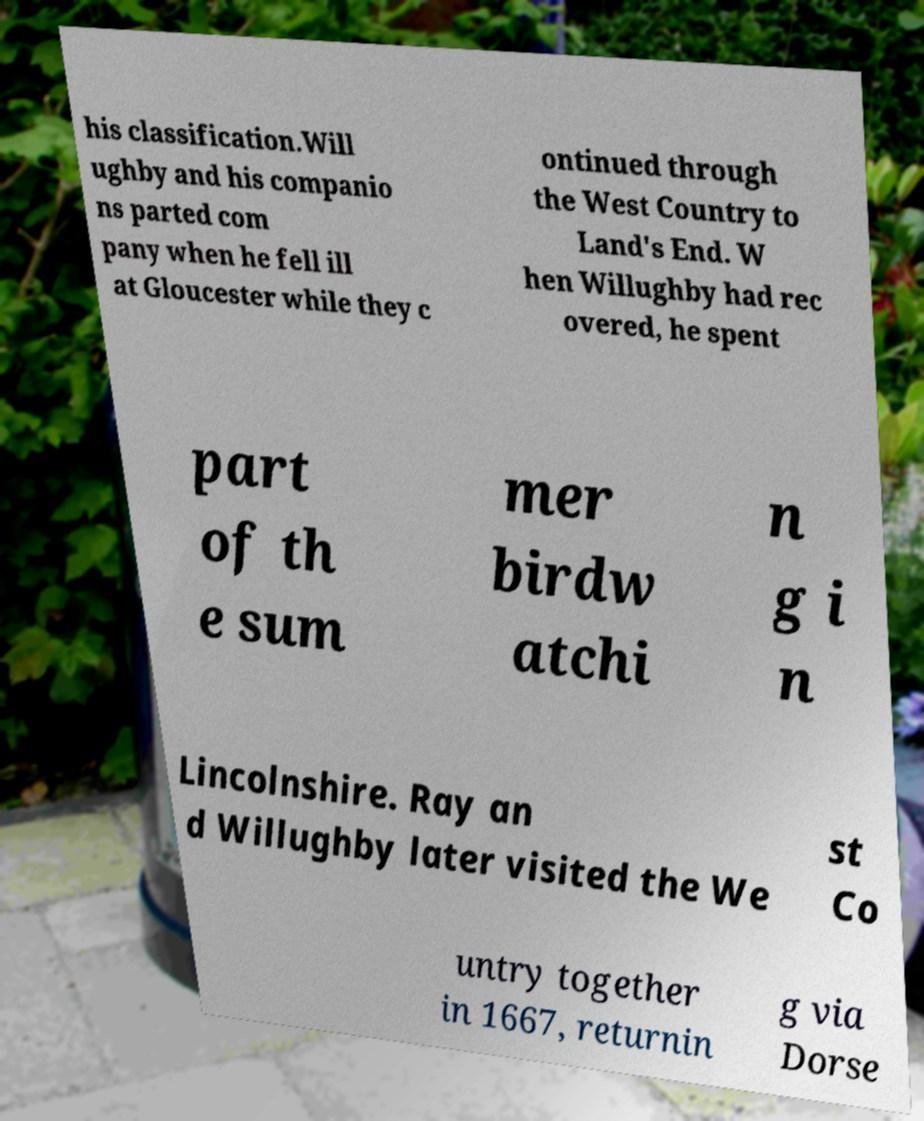For documentation purposes, I need the text within this image transcribed. Could you provide that? his classification.Will ughby and his companio ns parted com pany when he fell ill at Gloucester while they c ontinued through the West Country to Land's End. W hen Willughby had rec overed, he spent part of th e sum mer birdw atchi n g i n Lincolnshire. Ray an d Willughby later visited the We st Co untry together in 1667, returnin g via Dorse 